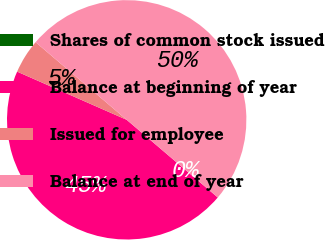<chart> <loc_0><loc_0><loc_500><loc_500><pie_chart><fcel>Shares of common stock issued<fcel>Balance at beginning of year<fcel>Issued for employee<fcel>Balance at end of year<nl><fcel>0.0%<fcel>45.36%<fcel>4.64%<fcel>50.0%<nl></chart> 